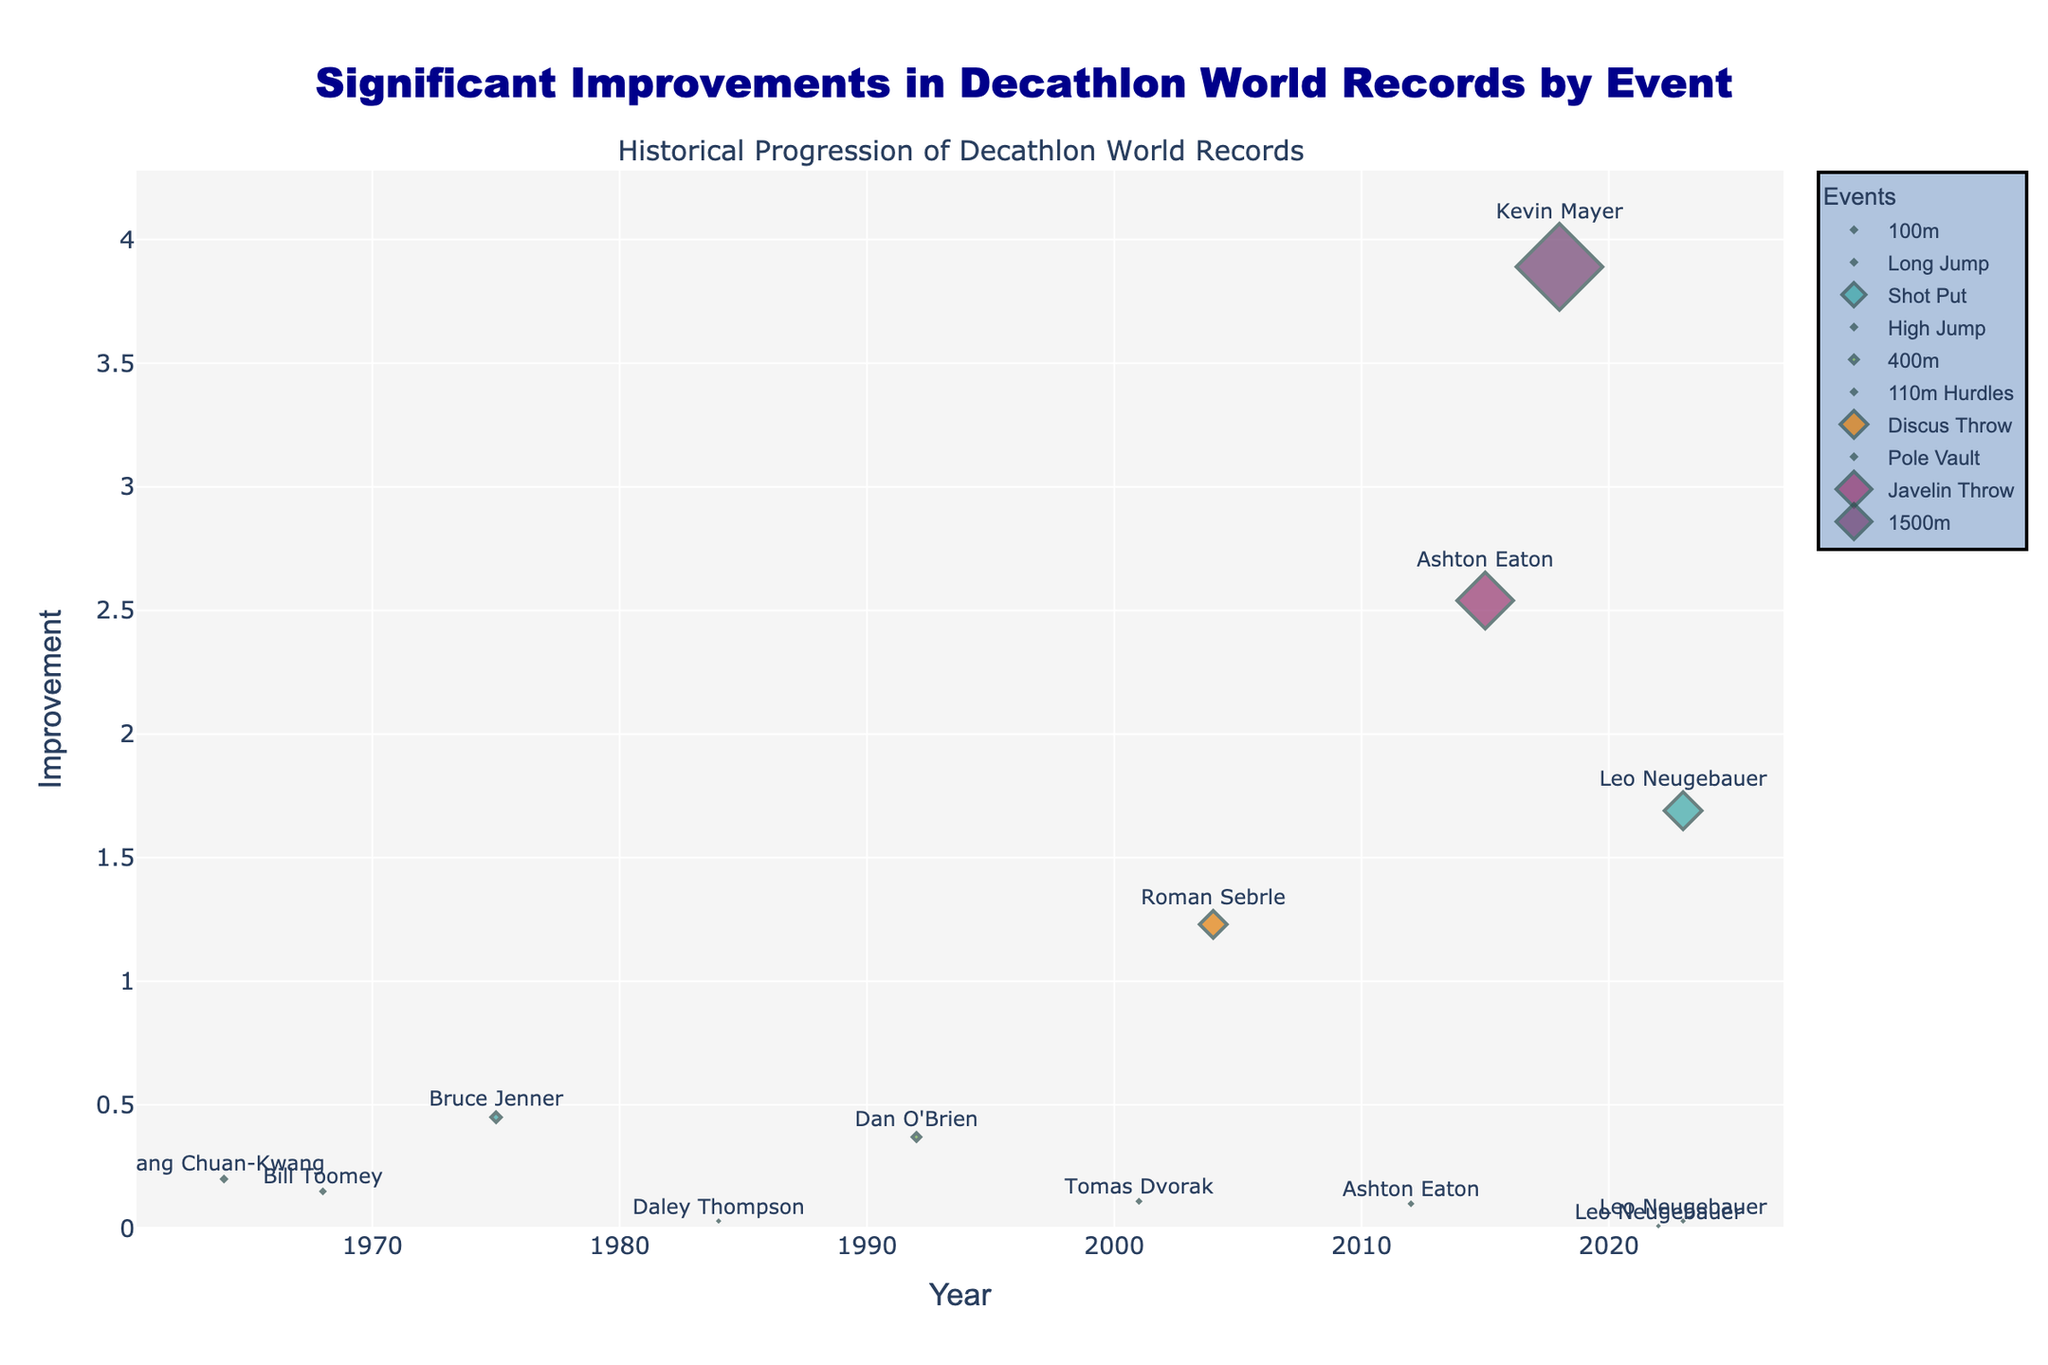What is the title of the plot? The title is visible at the top of the plot and is clearly stated.
Answer: Significant Improvements in Decathlon World Records by Event Which event had the most significant improvement in the 2010s? Examine the y-values corresponding to the 2010s and identify which event has the highest improvement value. The highest point is in 2015 for the Javelin Throw.
Answer: Javelin Throw How many events are plotted in the figure? Count the unique colors or legends, which represent different events.
Answer: 10 Who achieved the significant improvement in the 1500m event, and what was the improvement? Look for the 1500m event's data points and read the associated text.
Answer: Kevin Mayer, 3.89 Which event saw the greatest improvement, and what was the year of this improvement? Identify the highest y-value (improvement) on the plot and note the corresponding event and year. It was the Javelin Throw by Ashton Eaton in 2015.
Answer: Javelin Throw, 2015 In which year did Leo Neugebauer achieve significant improvements, and in which events? Look for the data points labeled "Leo Neugebauer" and list the corresponding years and events.
Answer: 2022 for 100m, 2023 for Long Jump and Shot Put What is the average improvement for events in the 2000s? Identify all data points in the 2000s, sum their improvements, and divide by the number of points. Improvements in the 2000s are 0.11 (110m Hurdles), 1.23 (Discus Throw), and 0.10 (Pole Vault), averaging to (0.11+1.23+0.10)/3 = 0.48.
Answer: 0.48 Compare the improvements in the Shot Put between Bruce Jenner in 1975 and Leo Neugebauer in 2023. Find the improvement values for both athletes in these years and calculate the difference. Leo Neugebauer's improvement in 2023 is 1.69, and Bruce Jenner's in 1975 is 0.45, the difference is 1.69 - 0.45 = 1.24.
Answer: Leo Neugebauer had a 1.24 greater improvement Which event had the smallest improvement, and what is the value of that improvement? Locate the point with the smallest y-value and note the label for the event and the numerical value.
Answer: 100m, 0.01 